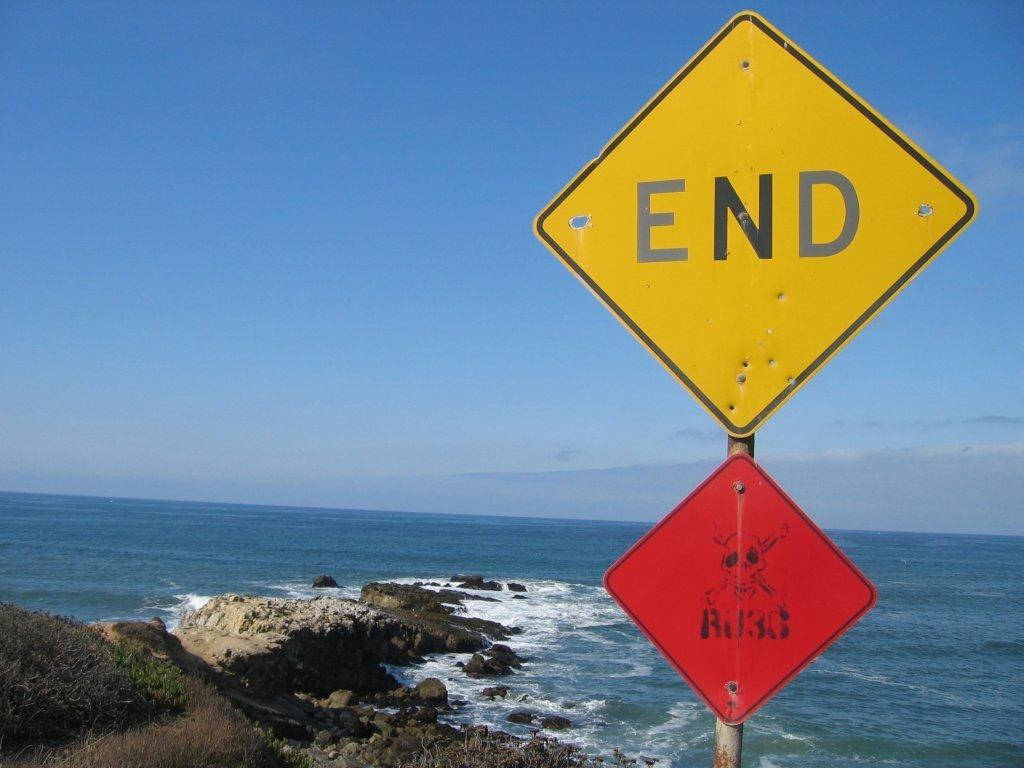<image>
Offer a succinct explanation of the picture presented. A yellow sign in the shape of a diamond that reads end on it. 